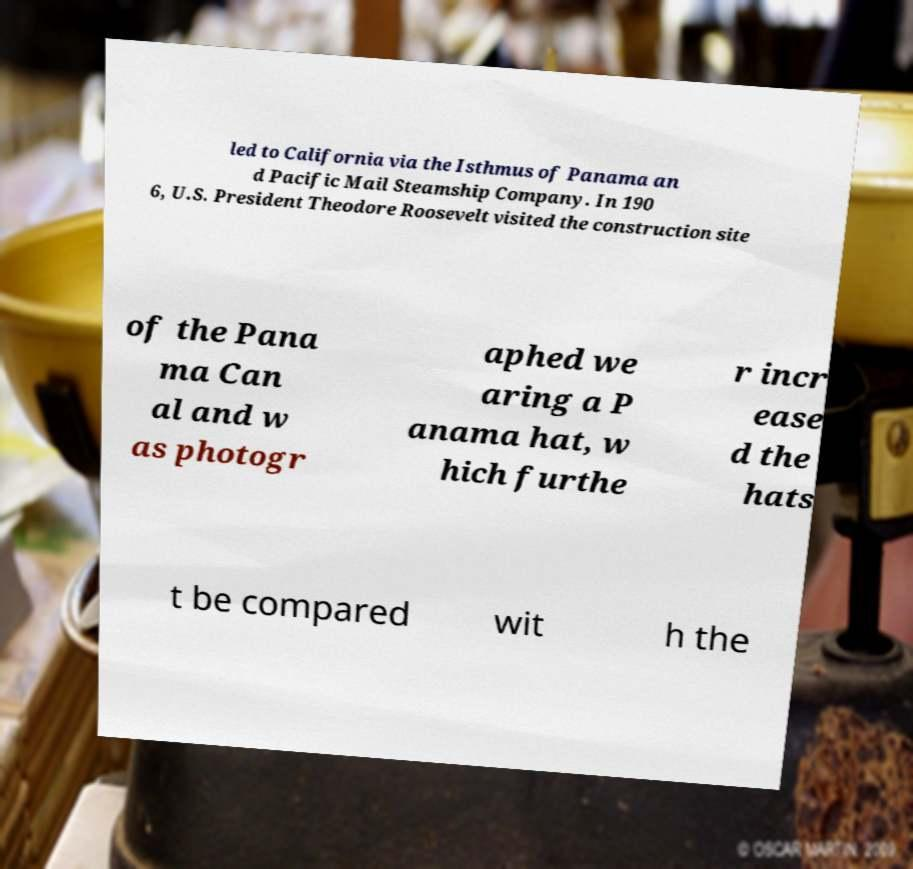Could you extract and type out the text from this image? led to California via the Isthmus of Panama an d Pacific Mail Steamship Company. In 190 6, U.S. President Theodore Roosevelt visited the construction site of the Pana ma Can al and w as photogr aphed we aring a P anama hat, w hich furthe r incr ease d the hats t be compared wit h the 